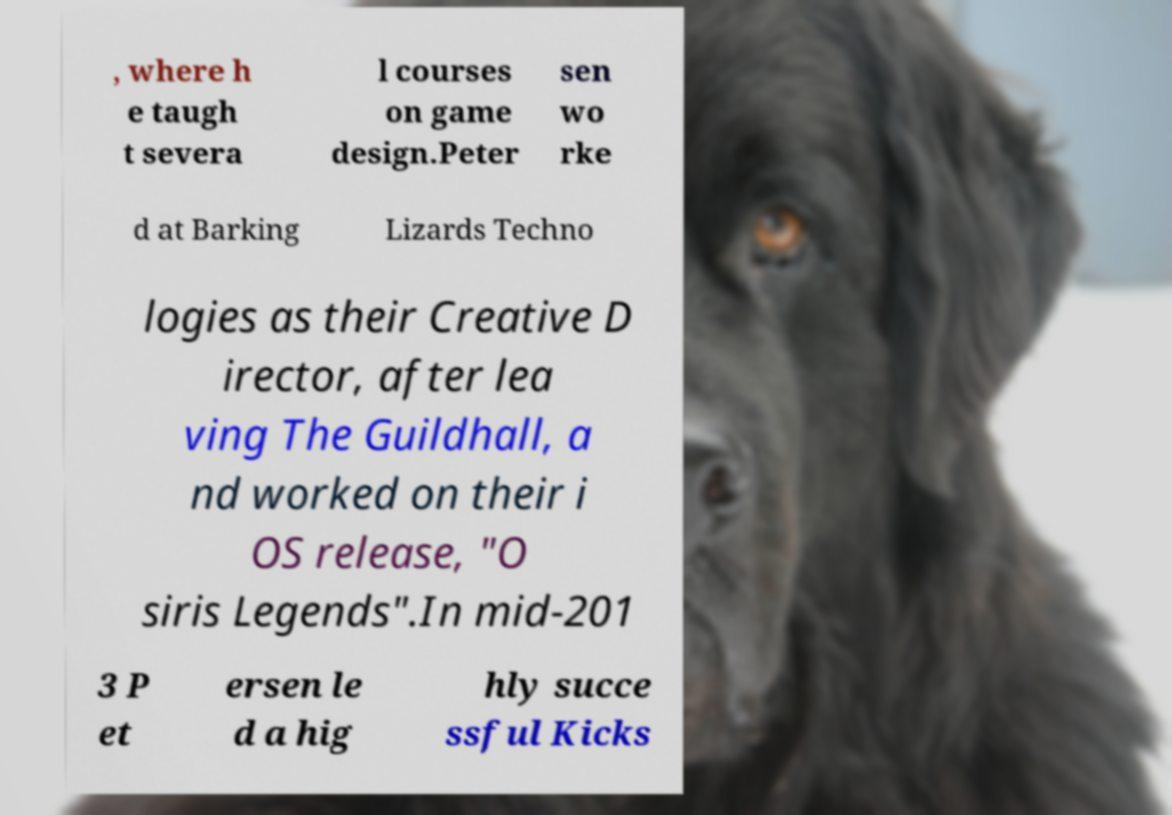Could you assist in decoding the text presented in this image and type it out clearly? , where h e taugh t severa l courses on game design.Peter sen wo rke d at Barking Lizards Techno logies as their Creative D irector, after lea ving The Guildhall, a nd worked on their i OS release, "O siris Legends".In mid-201 3 P et ersen le d a hig hly succe ssful Kicks 